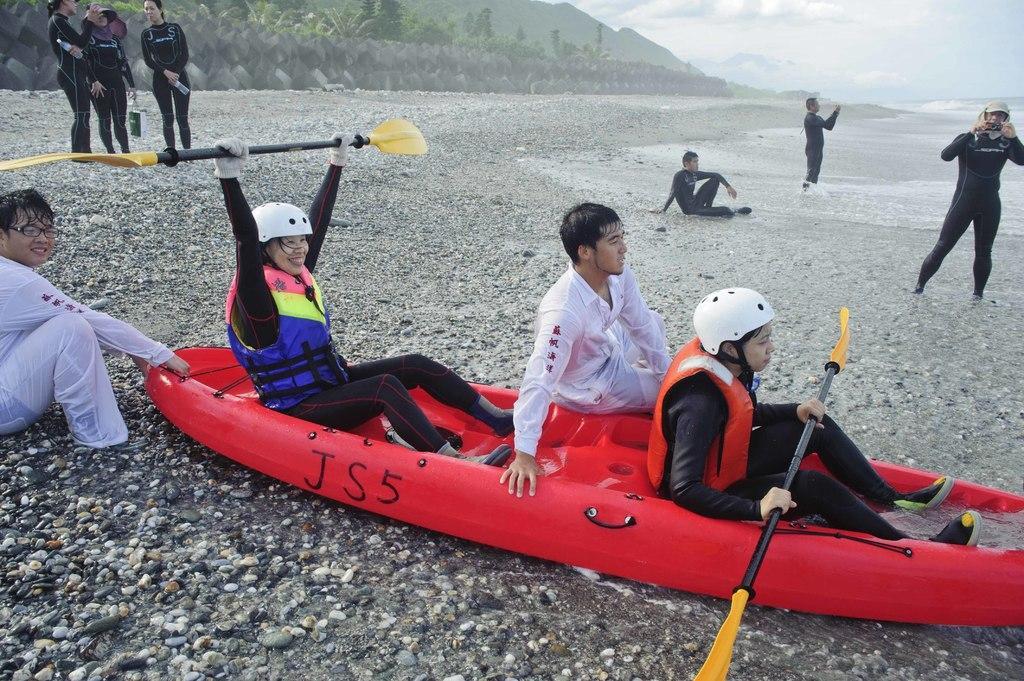How would you summarize this image in a sentence or two? This image is clicked outside. There is a small boat in the middle. There are some persons in this image. This looks like a beach. 